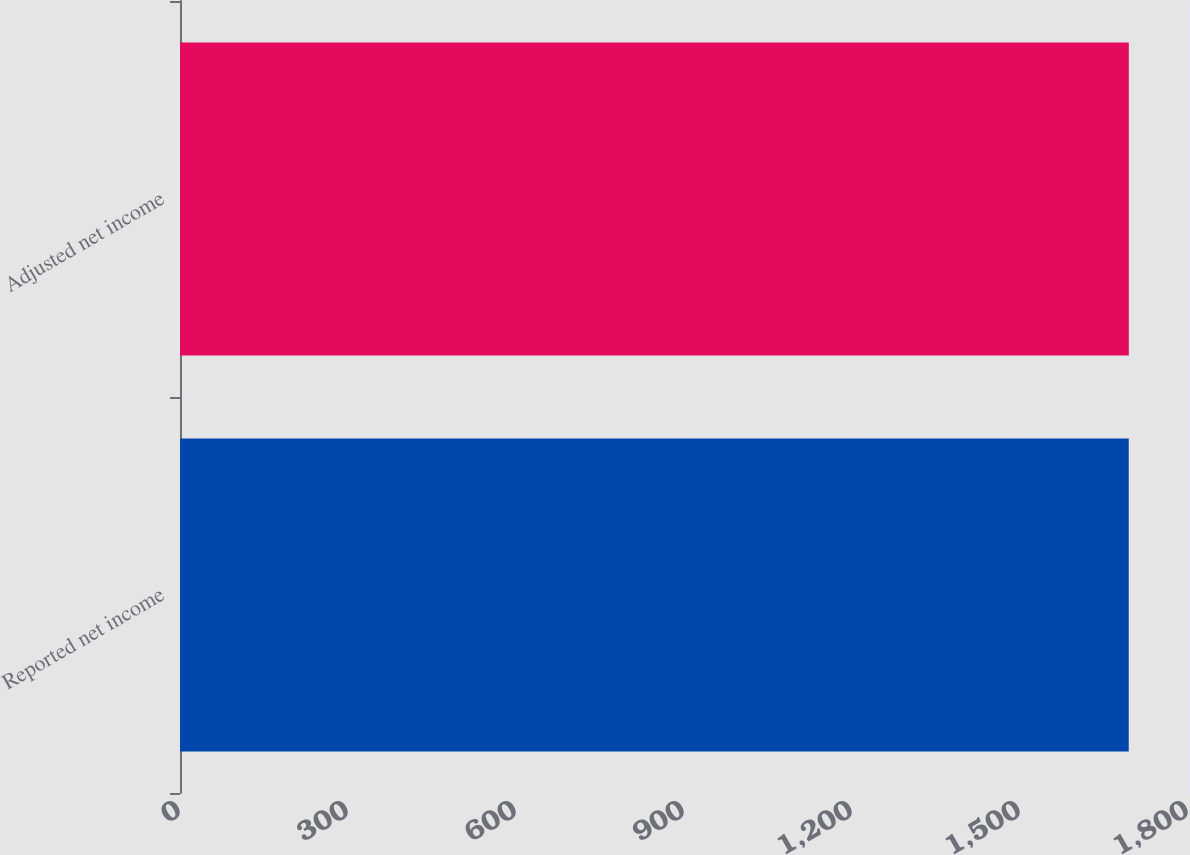Convert chart to OTSL. <chart><loc_0><loc_0><loc_500><loc_500><bar_chart><fcel>Reported net income<fcel>Adjusted net income<nl><fcel>1694.2<fcel>1694.3<nl></chart> 